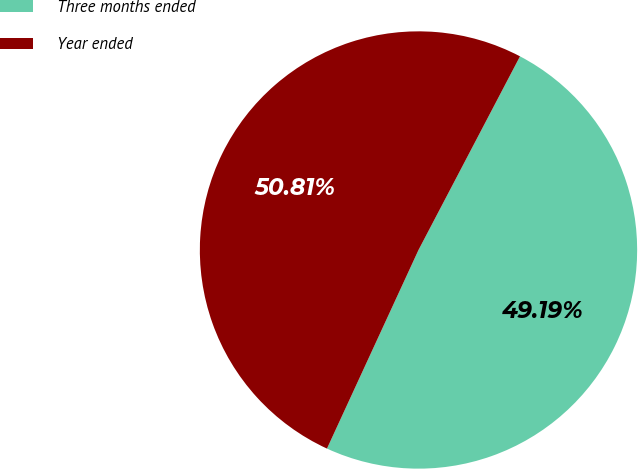Convert chart. <chart><loc_0><loc_0><loc_500><loc_500><pie_chart><fcel>Three months ended<fcel>Year ended<nl><fcel>49.19%<fcel>50.81%<nl></chart> 